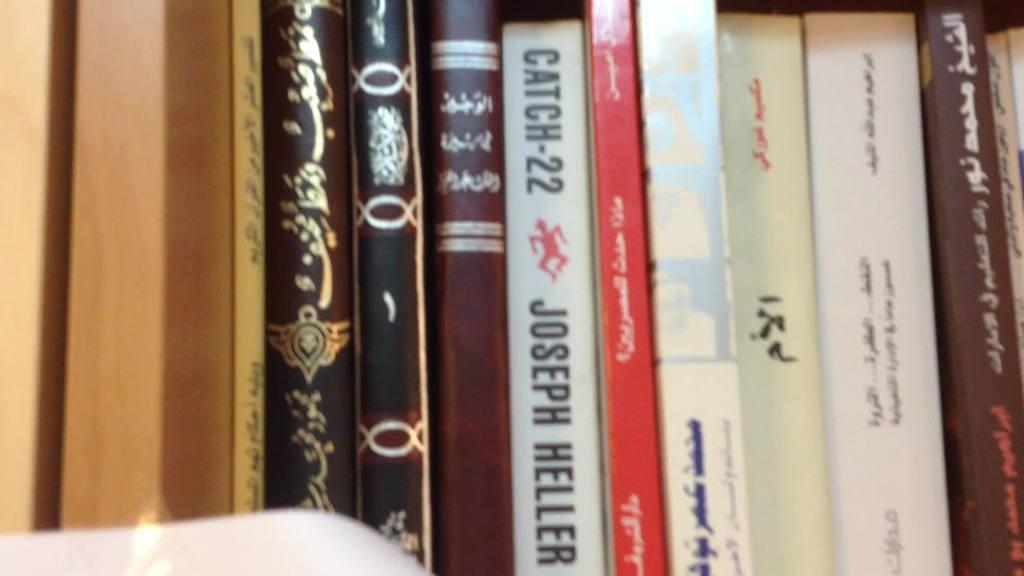<image>
Describe the image concisely. A collection of books on a shelf includes a copy of Catch-22. 